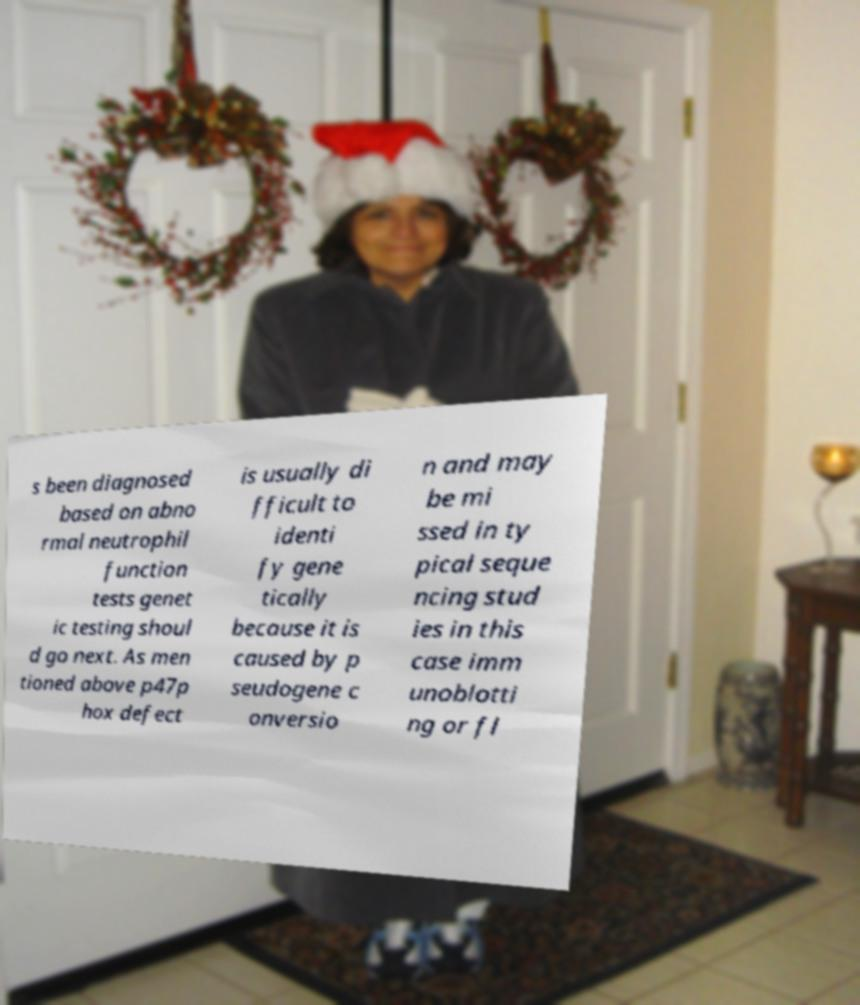Could you assist in decoding the text presented in this image and type it out clearly? s been diagnosed based on abno rmal neutrophil function tests genet ic testing shoul d go next. As men tioned above p47p hox defect is usually di fficult to identi fy gene tically because it is caused by p seudogene c onversio n and may be mi ssed in ty pical seque ncing stud ies in this case imm unoblotti ng or fl 